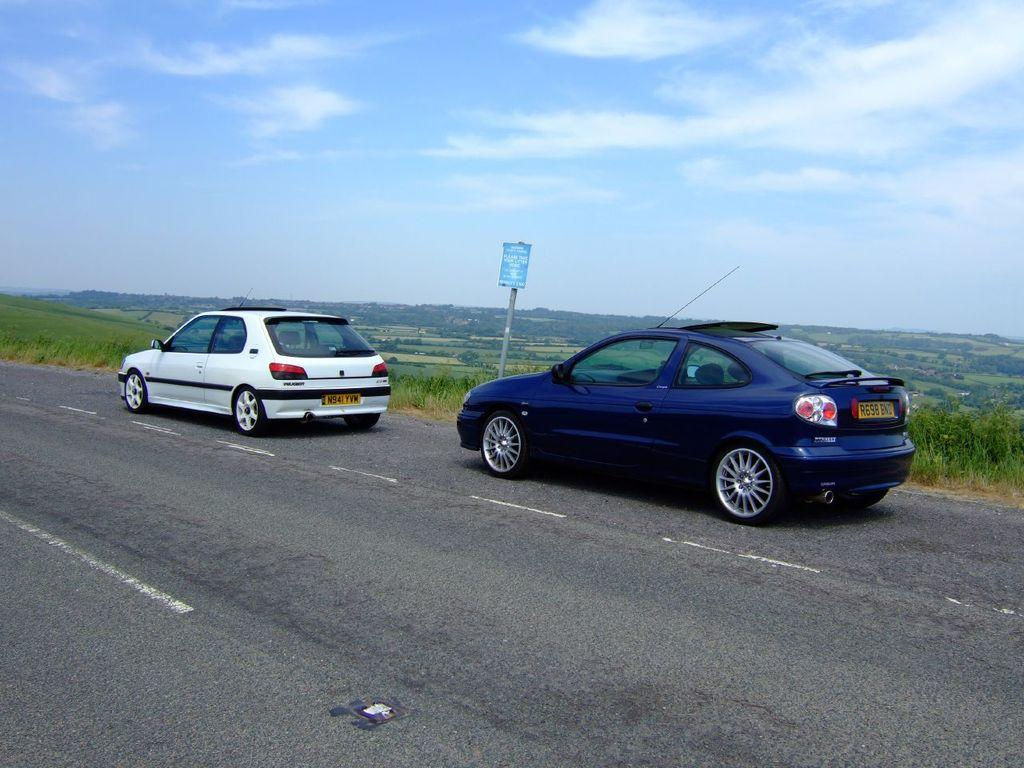What type of vehicles can be seen on the road in the image? There are cars on the road in the image. What is written on the board with text in the image? The specific text on the board cannot be determined from the image. What type of natural vegetation is visible in the image? There are trees visible in the image. How would you describe the sky in the image? The sky is blue and cloudy in the image. Can you tell me the income of the cow in the image? There is no cow present in the image, so it is not possible to determine its income. What type of boat is visible in the image? There is no boat present in the image. 